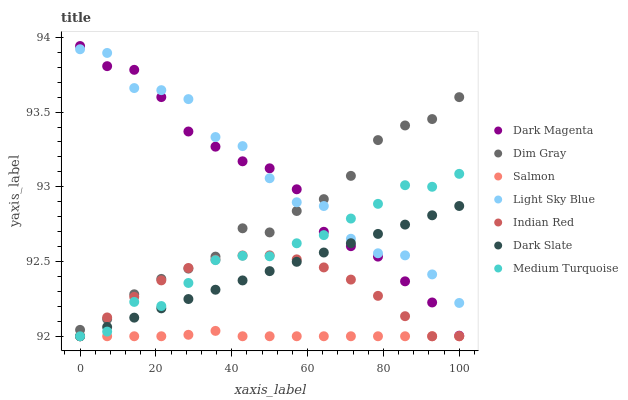Does Salmon have the minimum area under the curve?
Answer yes or no. Yes. Does Light Sky Blue have the maximum area under the curve?
Answer yes or no. Yes. Does Dim Gray have the minimum area under the curve?
Answer yes or no. No. Does Dim Gray have the maximum area under the curve?
Answer yes or no. No. Is Dark Slate the smoothest?
Answer yes or no. Yes. Is Light Sky Blue the roughest?
Answer yes or no. Yes. Is Dim Gray the smoothest?
Answer yes or no. No. Is Dim Gray the roughest?
Answer yes or no. No. Does Medium Turquoise have the lowest value?
Answer yes or no. Yes. Does Dim Gray have the lowest value?
Answer yes or no. No. Does Dark Magenta have the highest value?
Answer yes or no. Yes. Does Dim Gray have the highest value?
Answer yes or no. No. Is Medium Turquoise less than Dim Gray?
Answer yes or no. Yes. Is Dark Magenta greater than Salmon?
Answer yes or no. Yes. Does Dark Magenta intersect Dark Slate?
Answer yes or no. Yes. Is Dark Magenta less than Dark Slate?
Answer yes or no. No. Is Dark Magenta greater than Dark Slate?
Answer yes or no. No. Does Medium Turquoise intersect Dim Gray?
Answer yes or no. No. 